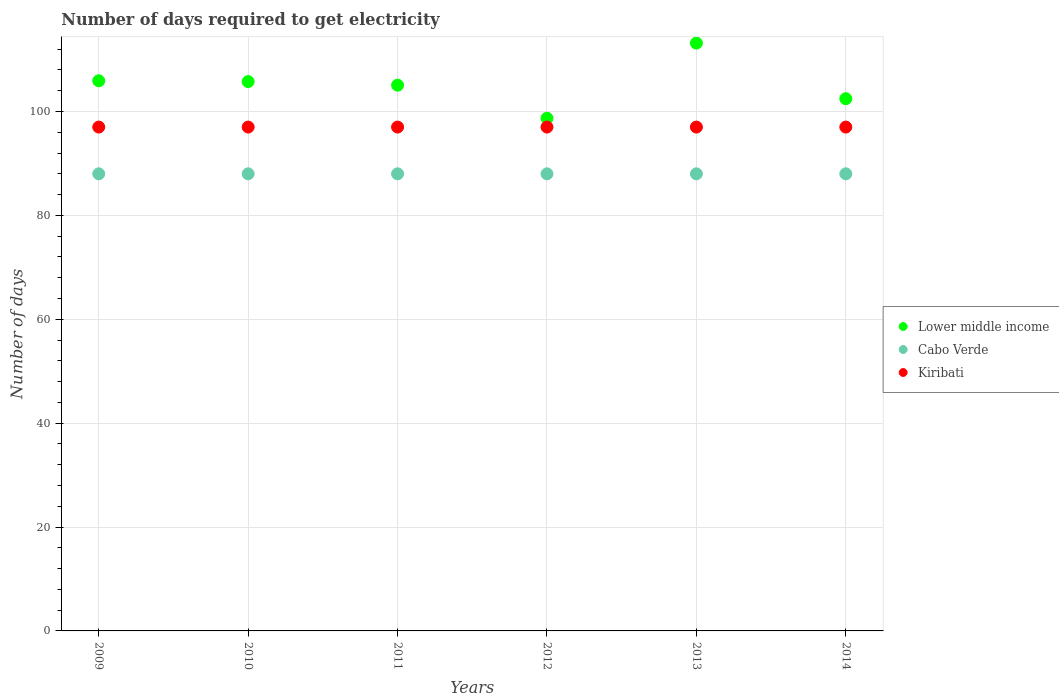How many different coloured dotlines are there?
Your answer should be compact. 3. What is the number of days required to get electricity in in Cabo Verde in 2009?
Keep it short and to the point. 88. Across all years, what is the maximum number of days required to get electricity in in Kiribati?
Make the answer very short. 97. Across all years, what is the minimum number of days required to get electricity in in Cabo Verde?
Your answer should be very brief. 88. In which year was the number of days required to get electricity in in Kiribati maximum?
Your answer should be compact. 2009. What is the total number of days required to get electricity in in Lower middle income in the graph?
Provide a short and direct response. 631.05. What is the difference between the number of days required to get electricity in in Lower middle income in 2014 and the number of days required to get electricity in in Kiribati in 2009?
Make the answer very short. 5.46. In the year 2010, what is the difference between the number of days required to get electricity in in Cabo Verde and number of days required to get electricity in in Lower middle income?
Your answer should be very brief. -17.76. In how many years, is the number of days required to get electricity in in Cabo Verde greater than 32 days?
Provide a short and direct response. 6. What is the ratio of the number of days required to get electricity in in Cabo Verde in 2010 to that in 2011?
Ensure brevity in your answer.  1. Is the number of days required to get electricity in in Cabo Verde in 2009 less than that in 2012?
Offer a terse response. No. What is the difference between the highest and the lowest number of days required to get electricity in in Kiribati?
Give a very brief answer. 0. Is the sum of the number of days required to get electricity in in Kiribati in 2009 and 2012 greater than the maximum number of days required to get electricity in in Cabo Verde across all years?
Provide a short and direct response. Yes. Is it the case that in every year, the sum of the number of days required to get electricity in in Lower middle income and number of days required to get electricity in in Kiribati  is greater than the number of days required to get electricity in in Cabo Verde?
Your answer should be compact. Yes. Does the number of days required to get electricity in in Cabo Verde monotonically increase over the years?
Keep it short and to the point. No. Is the number of days required to get electricity in in Lower middle income strictly less than the number of days required to get electricity in in Kiribati over the years?
Provide a short and direct response. No. How many years are there in the graph?
Offer a terse response. 6. What is the difference between two consecutive major ticks on the Y-axis?
Your answer should be very brief. 20. Are the values on the major ticks of Y-axis written in scientific E-notation?
Ensure brevity in your answer.  No. Where does the legend appear in the graph?
Offer a very short reply. Center right. How many legend labels are there?
Offer a terse response. 3. How are the legend labels stacked?
Provide a succinct answer. Vertical. What is the title of the graph?
Keep it short and to the point. Number of days required to get electricity. Does "Saudi Arabia" appear as one of the legend labels in the graph?
Your answer should be compact. No. What is the label or title of the Y-axis?
Offer a terse response. Number of days. What is the Number of days of Lower middle income in 2009?
Your answer should be very brief. 105.91. What is the Number of days in Cabo Verde in 2009?
Your answer should be very brief. 88. What is the Number of days in Kiribati in 2009?
Your answer should be very brief. 97. What is the Number of days in Lower middle income in 2010?
Give a very brief answer. 105.76. What is the Number of days of Kiribati in 2010?
Make the answer very short. 97. What is the Number of days of Lower middle income in 2011?
Your answer should be very brief. 105.07. What is the Number of days of Kiribati in 2011?
Ensure brevity in your answer.  97. What is the Number of days of Lower middle income in 2012?
Ensure brevity in your answer.  98.7. What is the Number of days of Kiribati in 2012?
Provide a succinct answer. 97. What is the Number of days in Lower middle income in 2013?
Give a very brief answer. 113.16. What is the Number of days of Cabo Verde in 2013?
Your response must be concise. 88. What is the Number of days in Kiribati in 2013?
Your answer should be compact. 97. What is the Number of days in Lower middle income in 2014?
Make the answer very short. 102.46. What is the Number of days in Cabo Verde in 2014?
Keep it short and to the point. 88. What is the Number of days of Kiribati in 2014?
Your response must be concise. 97. Across all years, what is the maximum Number of days of Lower middle income?
Your response must be concise. 113.16. Across all years, what is the maximum Number of days of Kiribati?
Provide a short and direct response. 97. Across all years, what is the minimum Number of days of Lower middle income?
Offer a very short reply. 98.7. Across all years, what is the minimum Number of days of Kiribati?
Offer a very short reply. 97. What is the total Number of days in Lower middle income in the graph?
Your answer should be compact. 631.05. What is the total Number of days in Cabo Verde in the graph?
Provide a succinct answer. 528. What is the total Number of days of Kiribati in the graph?
Provide a succinct answer. 582. What is the difference between the Number of days of Lower middle income in 2009 and that in 2010?
Offer a terse response. 0.16. What is the difference between the Number of days of Kiribati in 2009 and that in 2010?
Provide a succinct answer. 0. What is the difference between the Number of days of Lower middle income in 2009 and that in 2011?
Ensure brevity in your answer.  0.84. What is the difference between the Number of days of Cabo Verde in 2009 and that in 2011?
Offer a terse response. 0. What is the difference between the Number of days in Kiribati in 2009 and that in 2011?
Keep it short and to the point. 0. What is the difference between the Number of days of Lower middle income in 2009 and that in 2012?
Ensure brevity in your answer.  7.22. What is the difference between the Number of days in Cabo Verde in 2009 and that in 2012?
Your response must be concise. 0. What is the difference between the Number of days of Kiribati in 2009 and that in 2012?
Provide a succinct answer. 0. What is the difference between the Number of days of Lower middle income in 2009 and that in 2013?
Make the answer very short. -7.25. What is the difference between the Number of days of Kiribati in 2009 and that in 2013?
Give a very brief answer. 0. What is the difference between the Number of days in Lower middle income in 2009 and that in 2014?
Keep it short and to the point. 3.45. What is the difference between the Number of days in Kiribati in 2009 and that in 2014?
Give a very brief answer. 0. What is the difference between the Number of days in Lower middle income in 2010 and that in 2011?
Offer a terse response. 0.69. What is the difference between the Number of days in Lower middle income in 2010 and that in 2012?
Make the answer very short. 7.06. What is the difference between the Number of days in Cabo Verde in 2010 and that in 2012?
Provide a short and direct response. 0. What is the difference between the Number of days of Lower middle income in 2010 and that in 2013?
Provide a succinct answer. -7.41. What is the difference between the Number of days of Kiribati in 2010 and that in 2013?
Keep it short and to the point. 0. What is the difference between the Number of days in Lower middle income in 2010 and that in 2014?
Your response must be concise. 3.3. What is the difference between the Number of days of Cabo Verde in 2010 and that in 2014?
Offer a very short reply. 0. What is the difference between the Number of days of Lower middle income in 2011 and that in 2012?
Your response must be concise. 6.37. What is the difference between the Number of days in Kiribati in 2011 and that in 2012?
Ensure brevity in your answer.  0. What is the difference between the Number of days of Lower middle income in 2011 and that in 2013?
Your response must be concise. -8.1. What is the difference between the Number of days in Cabo Verde in 2011 and that in 2013?
Keep it short and to the point. 0. What is the difference between the Number of days in Lower middle income in 2011 and that in 2014?
Provide a succinct answer. 2.61. What is the difference between the Number of days in Cabo Verde in 2011 and that in 2014?
Your answer should be compact. 0. What is the difference between the Number of days in Kiribati in 2011 and that in 2014?
Your answer should be compact. 0. What is the difference between the Number of days of Lower middle income in 2012 and that in 2013?
Offer a very short reply. -14.47. What is the difference between the Number of days in Lower middle income in 2012 and that in 2014?
Keep it short and to the point. -3.76. What is the difference between the Number of days of Kiribati in 2012 and that in 2014?
Your answer should be compact. 0. What is the difference between the Number of days of Lower middle income in 2013 and that in 2014?
Provide a succinct answer. 10.7. What is the difference between the Number of days in Lower middle income in 2009 and the Number of days in Cabo Verde in 2010?
Ensure brevity in your answer.  17.91. What is the difference between the Number of days of Lower middle income in 2009 and the Number of days of Kiribati in 2010?
Offer a terse response. 8.91. What is the difference between the Number of days of Lower middle income in 2009 and the Number of days of Cabo Verde in 2011?
Give a very brief answer. 17.91. What is the difference between the Number of days in Lower middle income in 2009 and the Number of days in Kiribati in 2011?
Your answer should be very brief. 8.91. What is the difference between the Number of days of Lower middle income in 2009 and the Number of days of Cabo Verde in 2012?
Provide a short and direct response. 17.91. What is the difference between the Number of days of Lower middle income in 2009 and the Number of days of Kiribati in 2012?
Keep it short and to the point. 8.91. What is the difference between the Number of days of Lower middle income in 2009 and the Number of days of Cabo Verde in 2013?
Ensure brevity in your answer.  17.91. What is the difference between the Number of days of Lower middle income in 2009 and the Number of days of Kiribati in 2013?
Ensure brevity in your answer.  8.91. What is the difference between the Number of days in Cabo Verde in 2009 and the Number of days in Kiribati in 2013?
Your answer should be very brief. -9. What is the difference between the Number of days in Lower middle income in 2009 and the Number of days in Cabo Verde in 2014?
Your answer should be compact. 17.91. What is the difference between the Number of days of Lower middle income in 2009 and the Number of days of Kiribati in 2014?
Offer a very short reply. 8.91. What is the difference between the Number of days in Lower middle income in 2010 and the Number of days in Cabo Verde in 2011?
Your answer should be compact. 17.76. What is the difference between the Number of days of Lower middle income in 2010 and the Number of days of Kiribati in 2011?
Give a very brief answer. 8.76. What is the difference between the Number of days in Lower middle income in 2010 and the Number of days in Cabo Verde in 2012?
Keep it short and to the point. 17.76. What is the difference between the Number of days of Lower middle income in 2010 and the Number of days of Kiribati in 2012?
Your answer should be very brief. 8.76. What is the difference between the Number of days in Lower middle income in 2010 and the Number of days in Cabo Verde in 2013?
Offer a terse response. 17.76. What is the difference between the Number of days in Lower middle income in 2010 and the Number of days in Kiribati in 2013?
Your answer should be very brief. 8.76. What is the difference between the Number of days of Lower middle income in 2010 and the Number of days of Cabo Verde in 2014?
Your response must be concise. 17.76. What is the difference between the Number of days of Lower middle income in 2010 and the Number of days of Kiribati in 2014?
Your answer should be very brief. 8.76. What is the difference between the Number of days of Lower middle income in 2011 and the Number of days of Cabo Verde in 2012?
Ensure brevity in your answer.  17.07. What is the difference between the Number of days of Lower middle income in 2011 and the Number of days of Kiribati in 2012?
Offer a terse response. 8.07. What is the difference between the Number of days of Lower middle income in 2011 and the Number of days of Cabo Verde in 2013?
Provide a short and direct response. 17.07. What is the difference between the Number of days of Lower middle income in 2011 and the Number of days of Kiribati in 2013?
Make the answer very short. 8.07. What is the difference between the Number of days in Lower middle income in 2011 and the Number of days in Cabo Verde in 2014?
Your response must be concise. 17.07. What is the difference between the Number of days in Lower middle income in 2011 and the Number of days in Kiribati in 2014?
Provide a succinct answer. 8.07. What is the difference between the Number of days in Lower middle income in 2012 and the Number of days in Cabo Verde in 2013?
Your response must be concise. 10.7. What is the difference between the Number of days of Lower middle income in 2012 and the Number of days of Kiribati in 2013?
Ensure brevity in your answer.  1.7. What is the difference between the Number of days of Lower middle income in 2012 and the Number of days of Cabo Verde in 2014?
Provide a short and direct response. 10.7. What is the difference between the Number of days in Lower middle income in 2012 and the Number of days in Kiribati in 2014?
Give a very brief answer. 1.7. What is the difference between the Number of days in Lower middle income in 2013 and the Number of days in Cabo Verde in 2014?
Provide a short and direct response. 25.16. What is the difference between the Number of days in Lower middle income in 2013 and the Number of days in Kiribati in 2014?
Give a very brief answer. 16.16. What is the difference between the Number of days of Cabo Verde in 2013 and the Number of days of Kiribati in 2014?
Ensure brevity in your answer.  -9. What is the average Number of days in Lower middle income per year?
Give a very brief answer. 105.18. What is the average Number of days in Kiribati per year?
Make the answer very short. 97. In the year 2009, what is the difference between the Number of days in Lower middle income and Number of days in Cabo Verde?
Offer a terse response. 17.91. In the year 2009, what is the difference between the Number of days of Lower middle income and Number of days of Kiribati?
Offer a very short reply. 8.91. In the year 2010, what is the difference between the Number of days of Lower middle income and Number of days of Cabo Verde?
Offer a very short reply. 17.76. In the year 2010, what is the difference between the Number of days in Lower middle income and Number of days in Kiribati?
Ensure brevity in your answer.  8.76. In the year 2010, what is the difference between the Number of days of Cabo Verde and Number of days of Kiribati?
Give a very brief answer. -9. In the year 2011, what is the difference between the Number of days in Lower middle income and Number of days in Cabo Verde?
Provide a succinct answer. 17.07. In the year 2011, what is the difference between the Number of days of Lower middle income and Number of days of Kiribati?
Your response must be concise. 8.07. In the year 2012, what is the difference between the Number of days of Lower middle income and Number of days of Cabo Verde?
Ensure brevity in your answer.  10.7. In the year 2012, what is the difference between the Number of days of Lower middle income and Number of days of Kiribati?
Offer a terse response. 1.7. In the year 2012, what is the difference between the Number of days in Cabo Verde and Number of days in Kiribati?
Make the answer very short. -9. In the year 2013, what is the difference between the Number of days of Lower middle income and Number of days of Cabo Verde?
Offer a very short reply. 25.16. In the year 2013, what is the difference between the Number of days of Lower middle income and Number of days of Kiribati?
Make the answer very short. 16.16. In the year 2013, what is the difference between the Number of days in Cabo Verde and Number of days in Kiribati?
Your answer should be compact. -9. In the year 2014, what is the difference between the Number of days in Lower middle income and Number of days in Cabo Verde?
Your response must be concise. 14.46. In the year 2014, what is the difference between the Number of days of Lower middle income and Number of days of Kiribati?
Ensure brevity in your answer.  5.46. What is the ratio of the Number of days of Cabo Verde in 2009 to that in 2010?
Your response must be concise. 1. What is the ratio of the Number of days of Lower middle income in 2009 to that in 2011?
Keep it short and to the point. 1.01. What is the ratio of the Number of days in Cabo Verde in 2009 to that in 2011?
Your answer should be compact. 1. What is the ratio of the Number of days in Lower middle income in 2009 to that in 2012?
Offer a very short reply. 1.07. What is the ratio of the Number of days in Lower middle income in 2009 to that in 2013?
Offer a very short reply. 0.94. What is the ratio of the Number of days in Cabo Verde in 2009 to that in 2013?
Provide a succinct answer. 1. What is the ratio of the Number of days of Kiribati in 2009 to that in 2013?
Ensure brevity in your answer.  1. What is the ratio of the Number of days in Lower middle income in 2009 to that in 2014?
Keep it short and to the point. 1.03. What is the ratio of the Number of days of Kiribati in 2009 to that in 2014?
Provide a short and direct response. 1. What is the ratio of the Number of days of Lower middle income in 2010 to that in 2011?
Ensure brevity in your answer.  1.01. What is the ratio of the Number of days in Cabo Verde in 2010 to that in 2011?
Offer a terse response. 1. What is the ratio of the Number of days of Kiribati in 2010 to that in 2011?
Provide a succinct answer. 1. What is the ratio of the Number of days of Lower middle income in 2010 to that in 2012?
Your answer should be very brief. 1.07. What is the ratio of the Number of days in Kiribati in 2010 to that in 2012?
Keep it short and to the point. 1. What is the ratio of the Number of days in Lower middle income in 2010 to that in 2013?
Ensure brevity in your answer.  0.93. What is the ratio of the Number of days in Lower middle income in 2010 to that in 2014?
Your response must be concise. 1.03. What is the ratio of the Number of days of Lower middle income in 2011 to that in 2012?
Your answer should be very brief. 1.06. What is the ratio of the Number of days of Cabo Verde in 2011 to that in 2012?
Keep it short and to the point. 1. What is the ratio of the Number of days in Lower middle income in 2011 to that in 2013?
Offer a terse response. 0.93. What is the ratio of the Number of days in Lower middle income in 2011 to that in 2014?
Your response must be concise. 1.03. What is the ratio of the Number of days of Lower middle income in 2012 to that in 2013?
Provide a short and direct response. 0.87. What is the ratio of the Number of days of Cabo Verde in 2012 to that in 2013?
Make the answer very short. 1. What is the ratio of the Number of days in Lower middle income in 2012 to that in 2014?
Make the answer very short. 0.96. What is the ratio of the Number of days in Cabo Verde in 2012 to that in 2014?
Your answer should be very brief. 1. What is the ratio of the Number of days in Kiribati in 2012 to that in 2014?
Your answer should be compact. 1. What is the ratio of the Number of days of Lower middle income in 2013 to that in 2014?
Make the answer very short. 1.1. What is the ratio of the Number of days of Cabo Verde in 2013 to that in 2014?
Make the answer very short. 1. What is the difference between the highest and the second highest Number of days in Lower middle income?
Provide a succinct answer. 7.25. What is the difference between the highest and the lowest Number of days in Lower middle income?
Your answer should be compact. 14.47. 